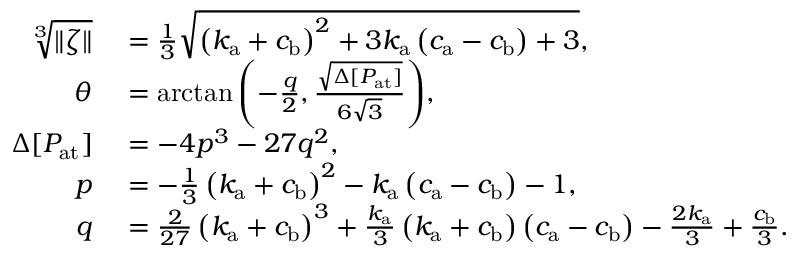Convert formula to latex. <formula><loc_0><loc_0><loc_500><loc_500>\begin{array} { r l } { \sqrt { [ } 3 ] { \| \zeta \| } } & = \frac { 1 } { 3 } \sqrt { \left ( k _ { a } + c _ { b } \right ) ^ { 2 } + 3 k _ { a } \left ( c _ { a } - c _ { b } \right ) + 3 } , } \\ { \theta } & = \arctan { \left ( - \frac { q } { 2 } , \frac { \sqrt { \Delta [ P _ { a t } ] } } { 6 \sqrt { 3 } } \right ) } , } \\ { \Delta [ P _ { a t } ] } & = - 4 p ^ { 3 } - 2 7 q ^ { 2 } , } \\ { p } & = - \frac { 1 } { 3 } \left ( k _ { a } + c _ { b } \right ) ^ { 2 } - k _ { a } \left ( c _ { a } - c _ { b } \right ) - 1 , } \\ { q } & = \frac { 2 } { 2 7 } \left ( k _ { a } + c _ { b } \right ) ^ { 3 } + \frac { k _ { a } } { 3 } \left ( k _ { a } + c _ { b } \right ) \left ( c _ { a } - c _ { b } \right ) - \frac { 2 k _ { a } } { 3 } + \frac { c _ { b } } { 3 } . } \end{array}</formula> 